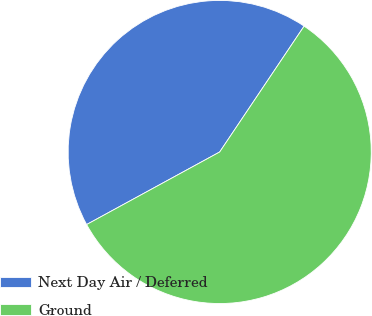<chart> <loc_0><loc_0><loc_500><loc_500><pie_chart><fcel>Next Day Air / Deferred<fcel>Ground<nl><fcel>42.35%<fcel>57.65%<nl></chart> 